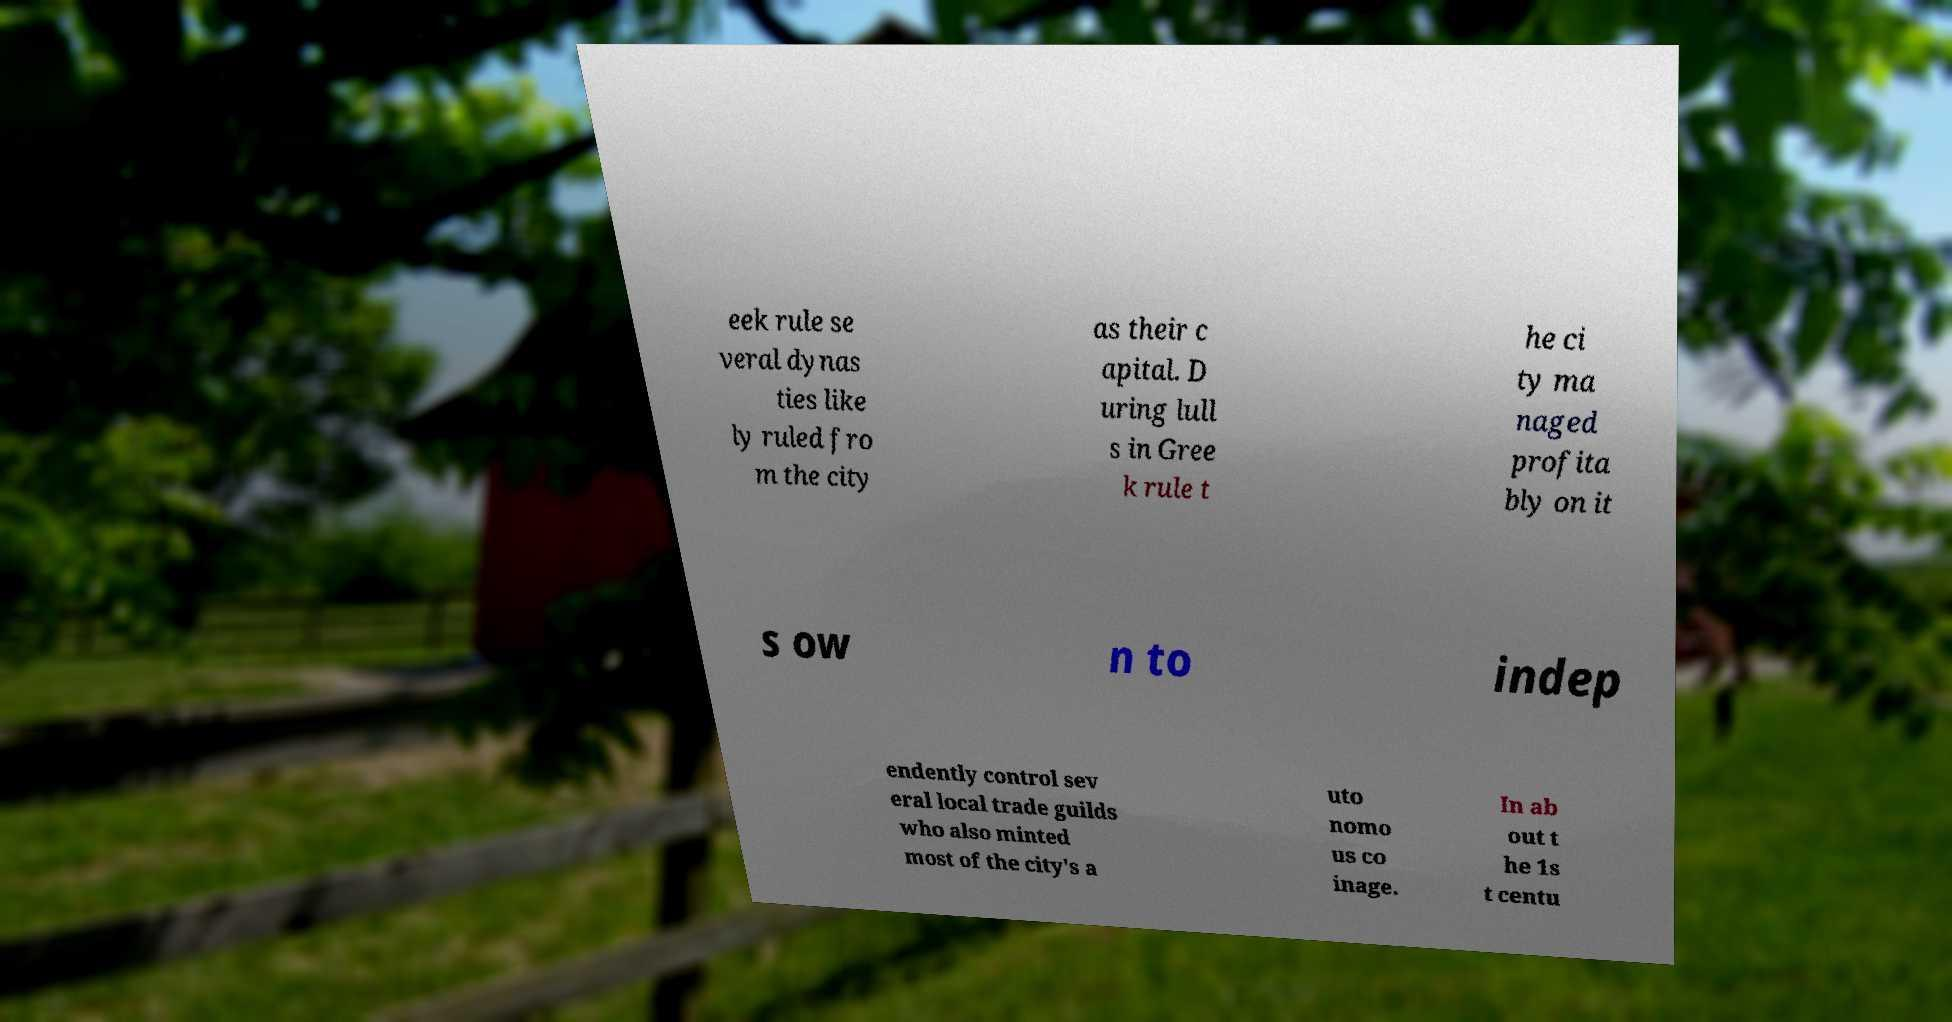There's text embedded in this image that I need extracted. Can you transcribe it verbatim? eek rule se veral dynas ties like ly ruled fro m the city as their c apital. D uring lull s in Gree k rule t he ci ty ma naged profita bly on it s ow n to indep endently control sev eral local trade guilds who also minted most of the city's a uto nomo us co inage. In ab out t he 1s t centu 